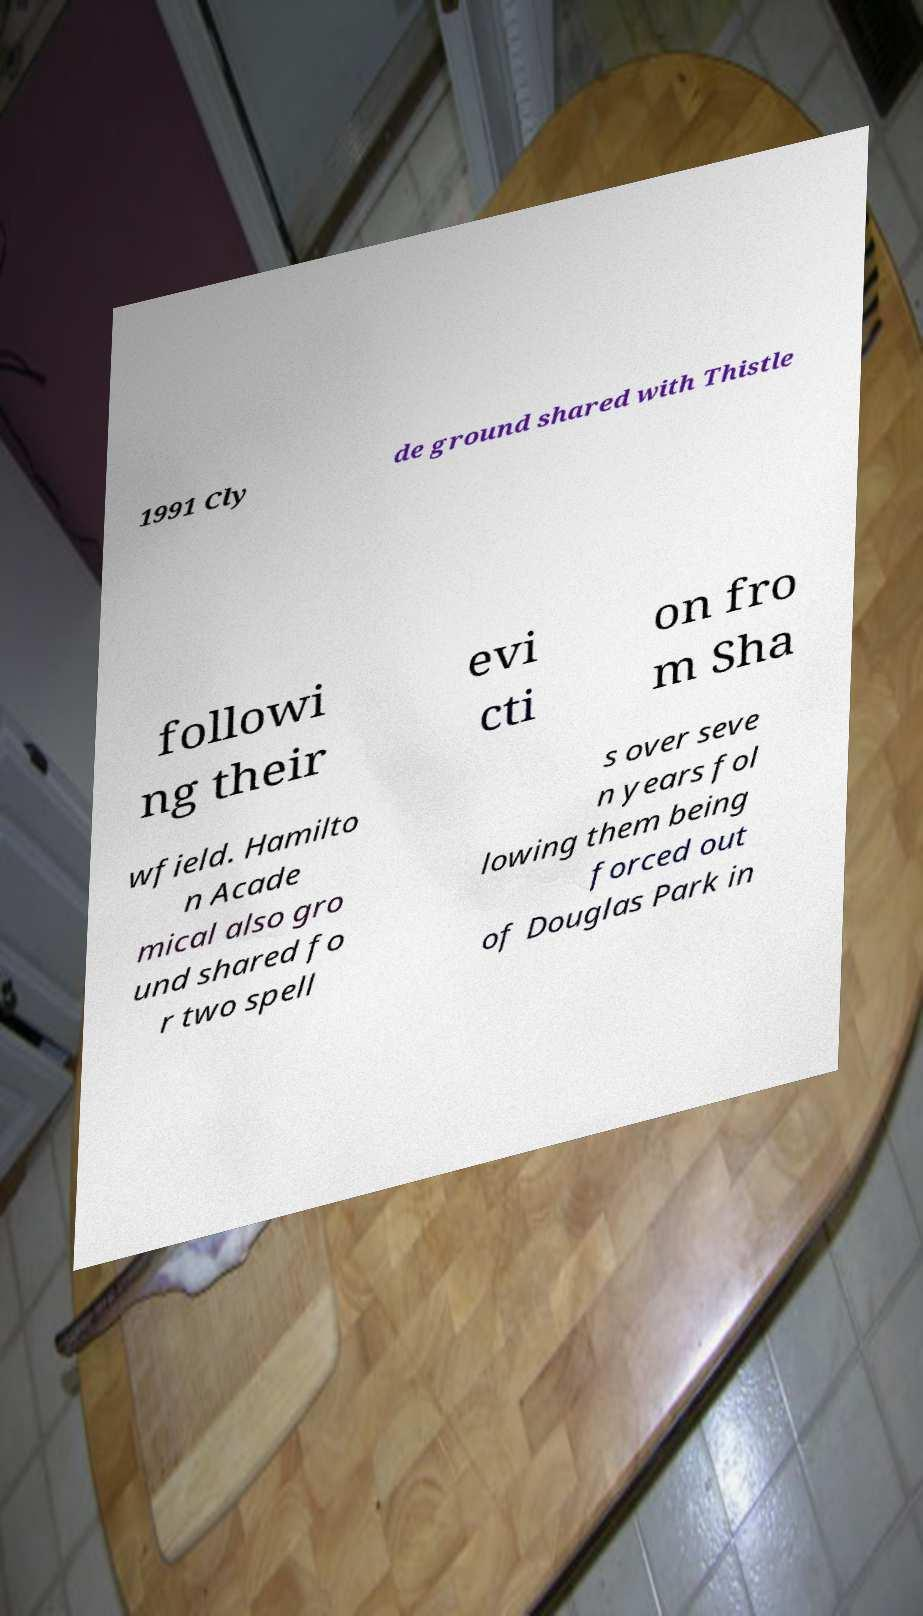Can you read and provide the text displayed in the image?This photo seems to have some interesting text. Can you extract and type it out for me? 1991 Cly de ground shared with Thistle followi ng their evi cti on fro m Sha wfield. Hamilto n Acade mical also gro und shared fo r two spell s over seve n years fol lowing them being forced out of Douglas Park in 